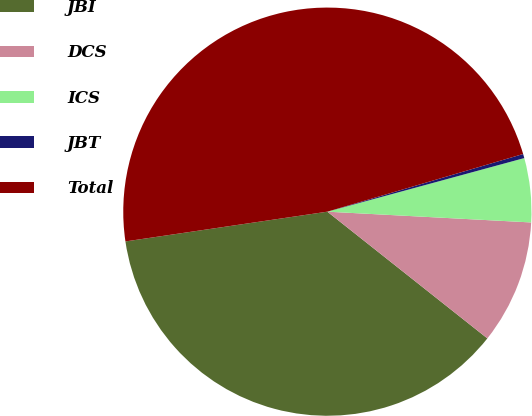Convert chart to OTSL. <chart><loc_0><loc_0><loc_500><loc_500><pie_chart><fcel>JBI<fcel>DCS<fcel>ICS<fcel>JBT<fcel>Total<nl><fcel>37.01%<fcel>9.82%<fcel>5.07%<fcel>0.33%<fcel>47.77%<nl></chart> 